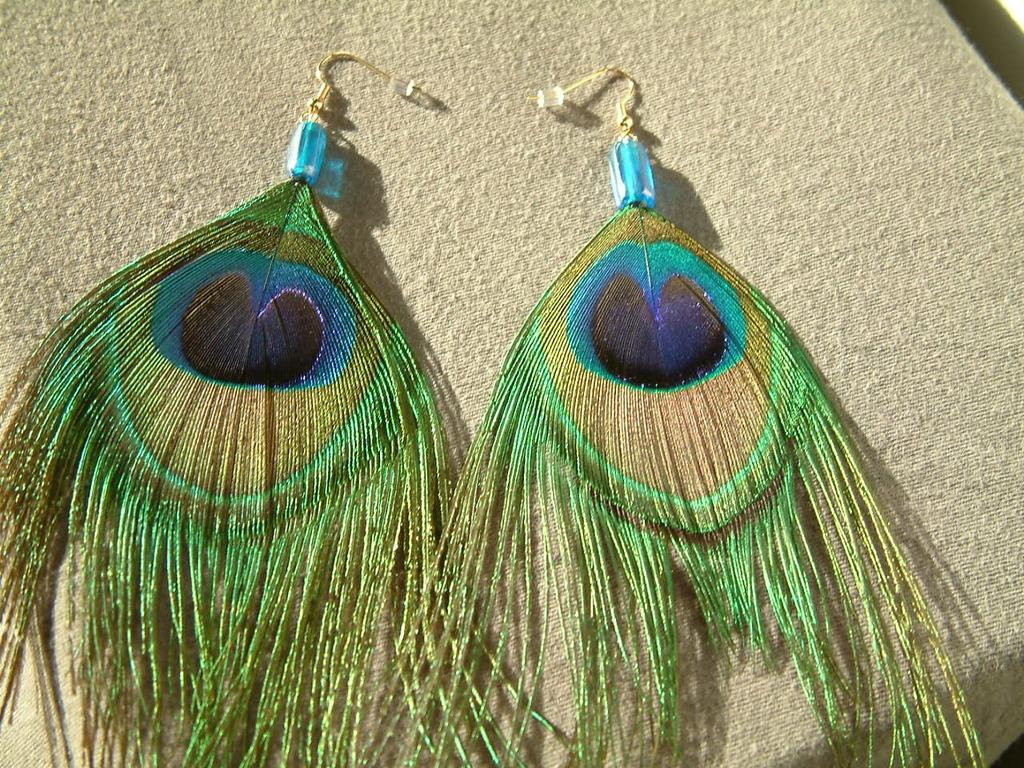What type of accessory is visible in the image? There is a pair of earrings in the image. Where are the earrings located? The earrings are on a surface. What type of cork is used to hold the earrings in place in the image? There is no cork present in the image; the earrings are simply on a surface. 